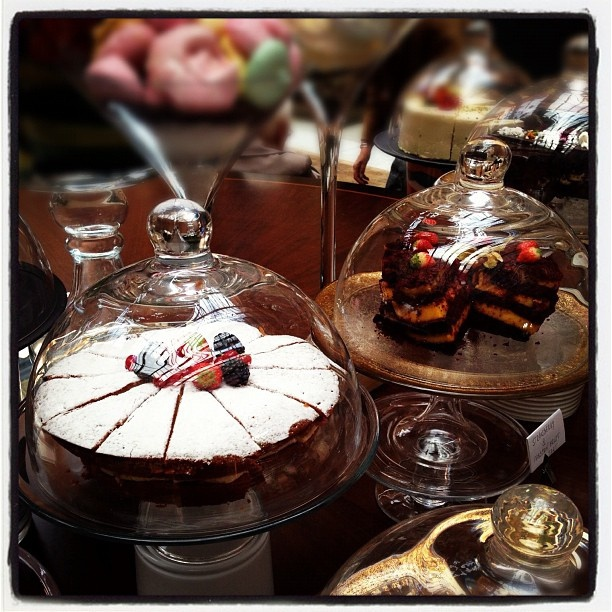Describe the objects in this image and their specific colors. I can see cake in white, black, maroon, and darkgray tones, bowl in white, black, maroon, and gray tones, dining table in white, black, maroon, and brown tones, cake in white, black, and maroon tones, and cake in white, black, lightgray, gray, and darkgray tones in this image. 